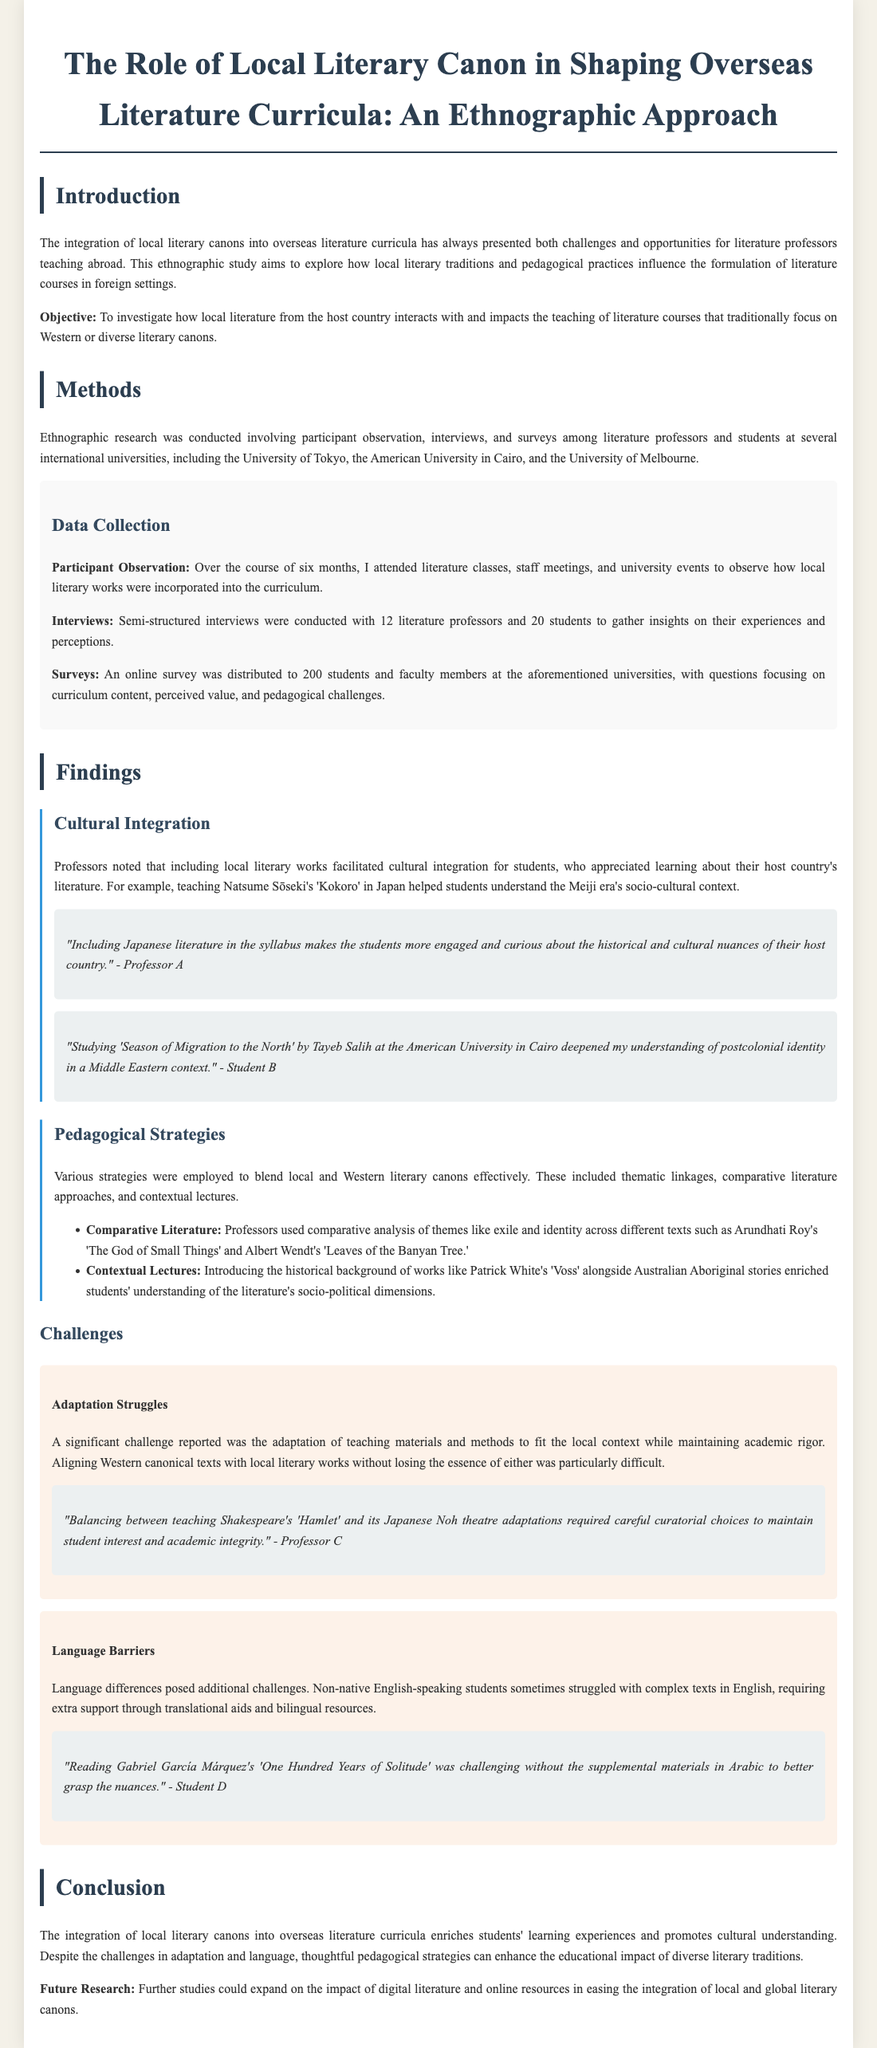What is the primary objective of the study? The objective of the study focuses on the interaction and impact of local literature on literature courses, particularly those that traditionally emphasize Western or diverse canons.
Answer: To investigate how local literature from the host country interacts with and impacts the teaching of literature courses that traditionally focus on Western or diverse literary canons How many professors were interviewed for the study? The document mentions that semi-structured interviews were conducted with a specific number of professors.
Answer: 12 Which universities were included in the study? The study involved multiple international universities, and the names of these institutions are explicitly stated in the document.
Answer: University of Tokyo, American University in Cairo, University of Melbourne What literary work is cited as a means to understand postcolonial identity at the American University in Cairo? A specific literary work is highlighted for its significance in offering insights into postcolonial identity.
Answer: Season of Migration to the North What challenge is associated with language differences? The document discusses a challenge related to understanding complex texts due to language barriers faced by non-native speakers.
Answer: Language barriers What pedagogical strategy involves comparing themes between texts? The document outlines various strategies, among which one focuses on the academic practice of comparing different texts based on their themes.
Answer: Comparative literature What does the study suggest for future research? The document offers insights on potential directions for further study, particularly related to digital resources.
Answer: Impact of digital literature and online resources What is cited as a significant challenge in adapting teaching materials? The document highlights a primary difficulty related to curriculum adaptation in teaching literature across cultural contexts.
Answer: Adaptation struggles 